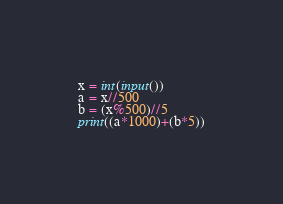<code> <loc_0><loc_0><loc_500><loc_500><_Python_>x = int(input())
a = x//500
b = (x%500)//5
print((a*1000)+(b*5))</code> 